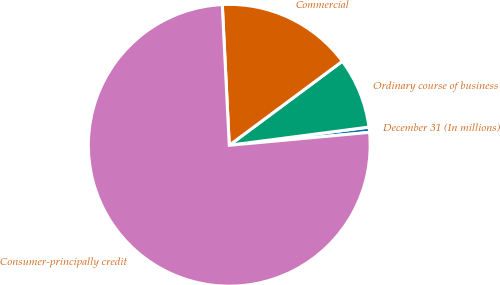Convert chart. <chart><loc_0><loc_0><loc_500><loc_500><pie_chart><fcel>December 31 (In millions)<fcel>Ordinary course of business<fcel>Commercial<fcel>Consumer-principally credit<nl><fcel>0.6%<fcel>8.11%<fcel>15.62%<fcel>75.67%<nl></chart> 